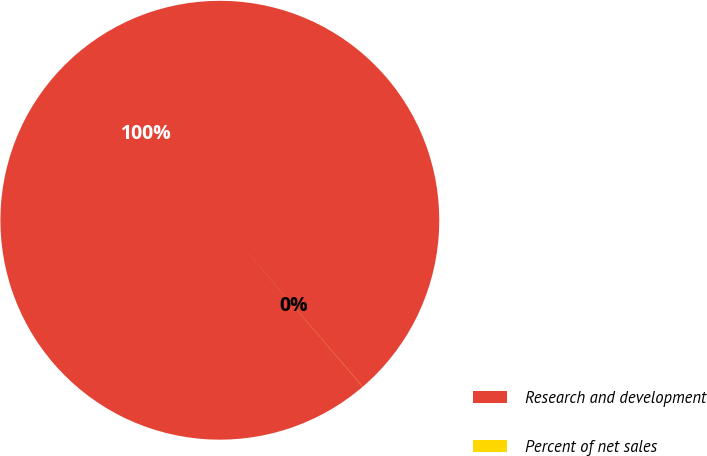<chart> <loc_0><loc_0><loc_500><loc_500><pie_chart><fcel>Research and development<fcel>Percent of net sales<nl><fcel>99.99%<fcel>0.01%<nl></chart> 